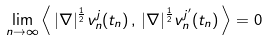<formula> <loc_0><loc_0><loc_500><loc_500>\lim _ { n \to \infty } \left \langle \, | \nabla | ^ { \frac { 1 } { 2 } } v _ { n } ^ { j } ( t _ { n } ) \, , \, | \nabla | ^ { \frac { 1 } { 2 } } v _ { n } ^ { j ^ { \prime } } ( t _ { n } ) \, \right \rangle = 0</formula> 